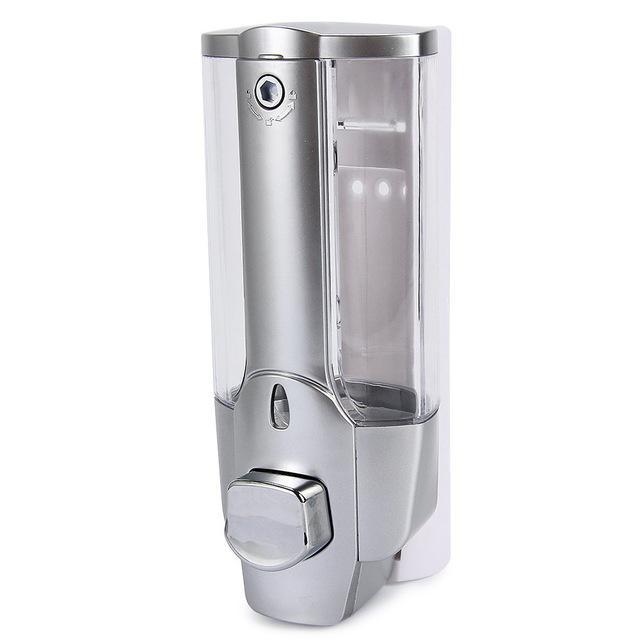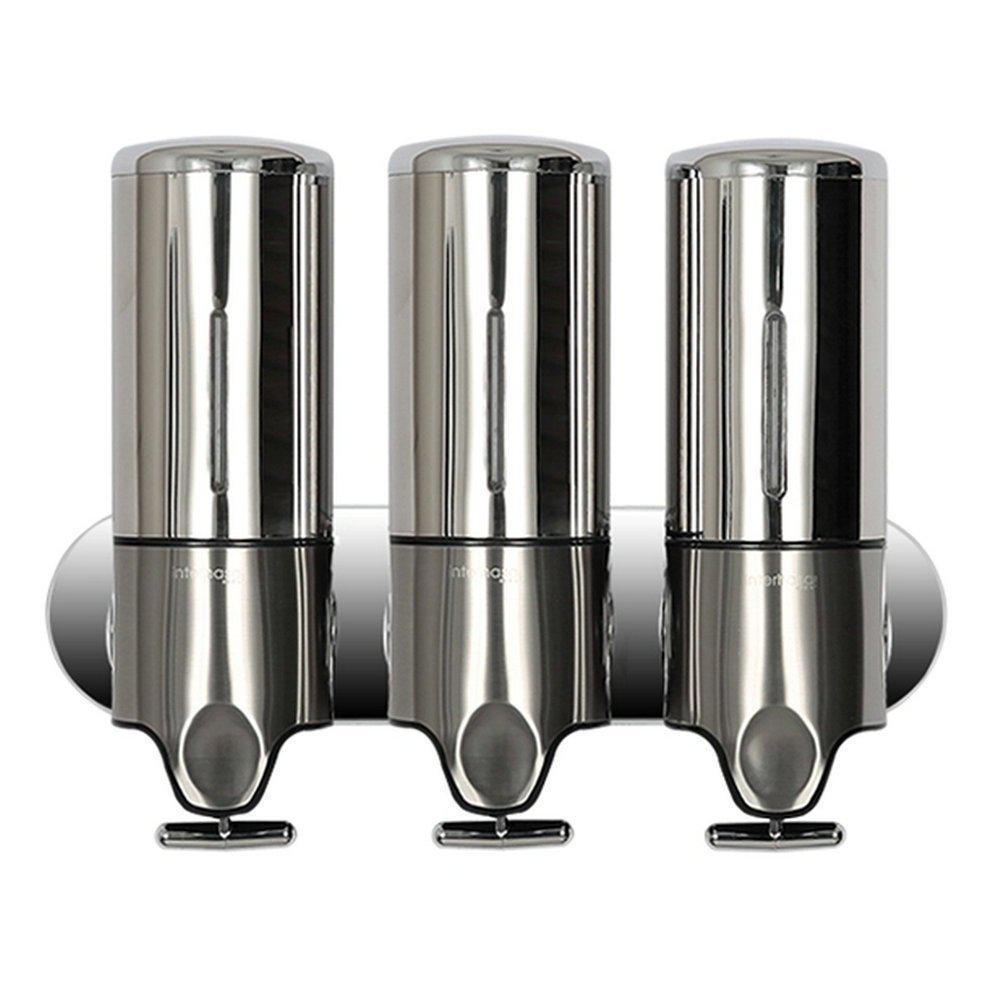The first image is the image on the left, the second image is the image on the right. Assess this claim about the two images: "One of the dispensers is brown and silver.". Correct or not? Answer yes or no. No. 